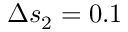<formula> <loc_0><loc_0><loc_500><loc_500>\Delta s _ { 2 } = 0 . 1</formula> 